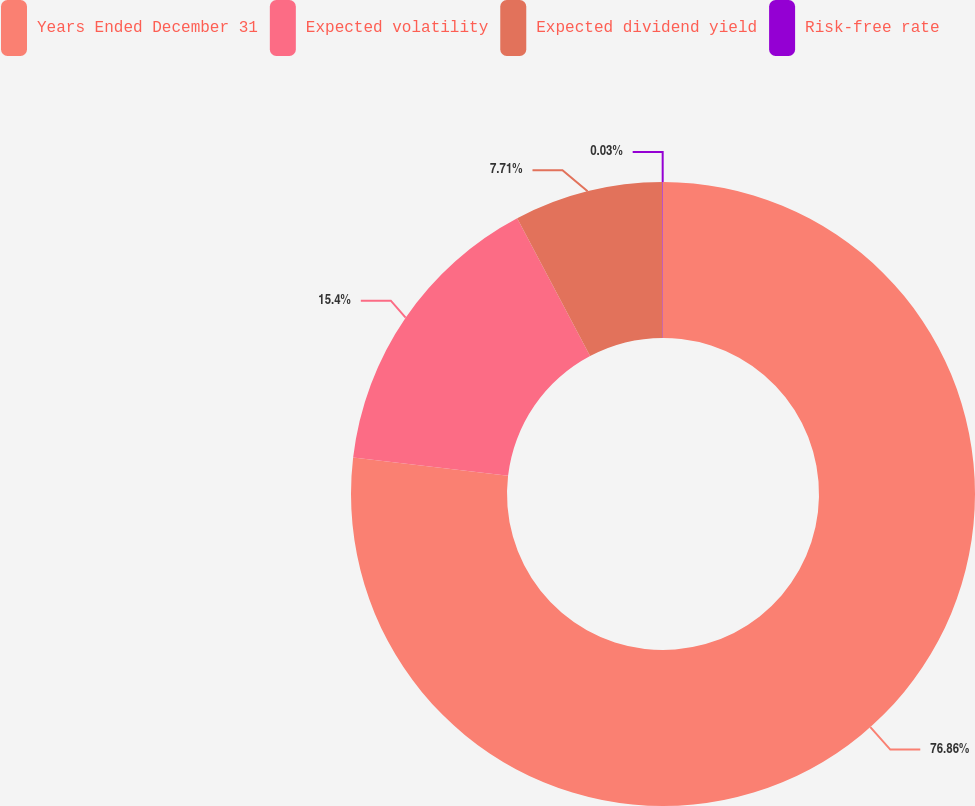Convert chart. <chart><loc_0><loc_0><loc_500><loc_500><pie_chart><fcel>Years Ended December 31<fcel>Expected volatility<fcel>Expected dividend yield<fcel>Risk-free rate<nl><fcel>76.86%<fcel>15.4%<fcel>7.71%<fcel>0.03%<nl></chart> 